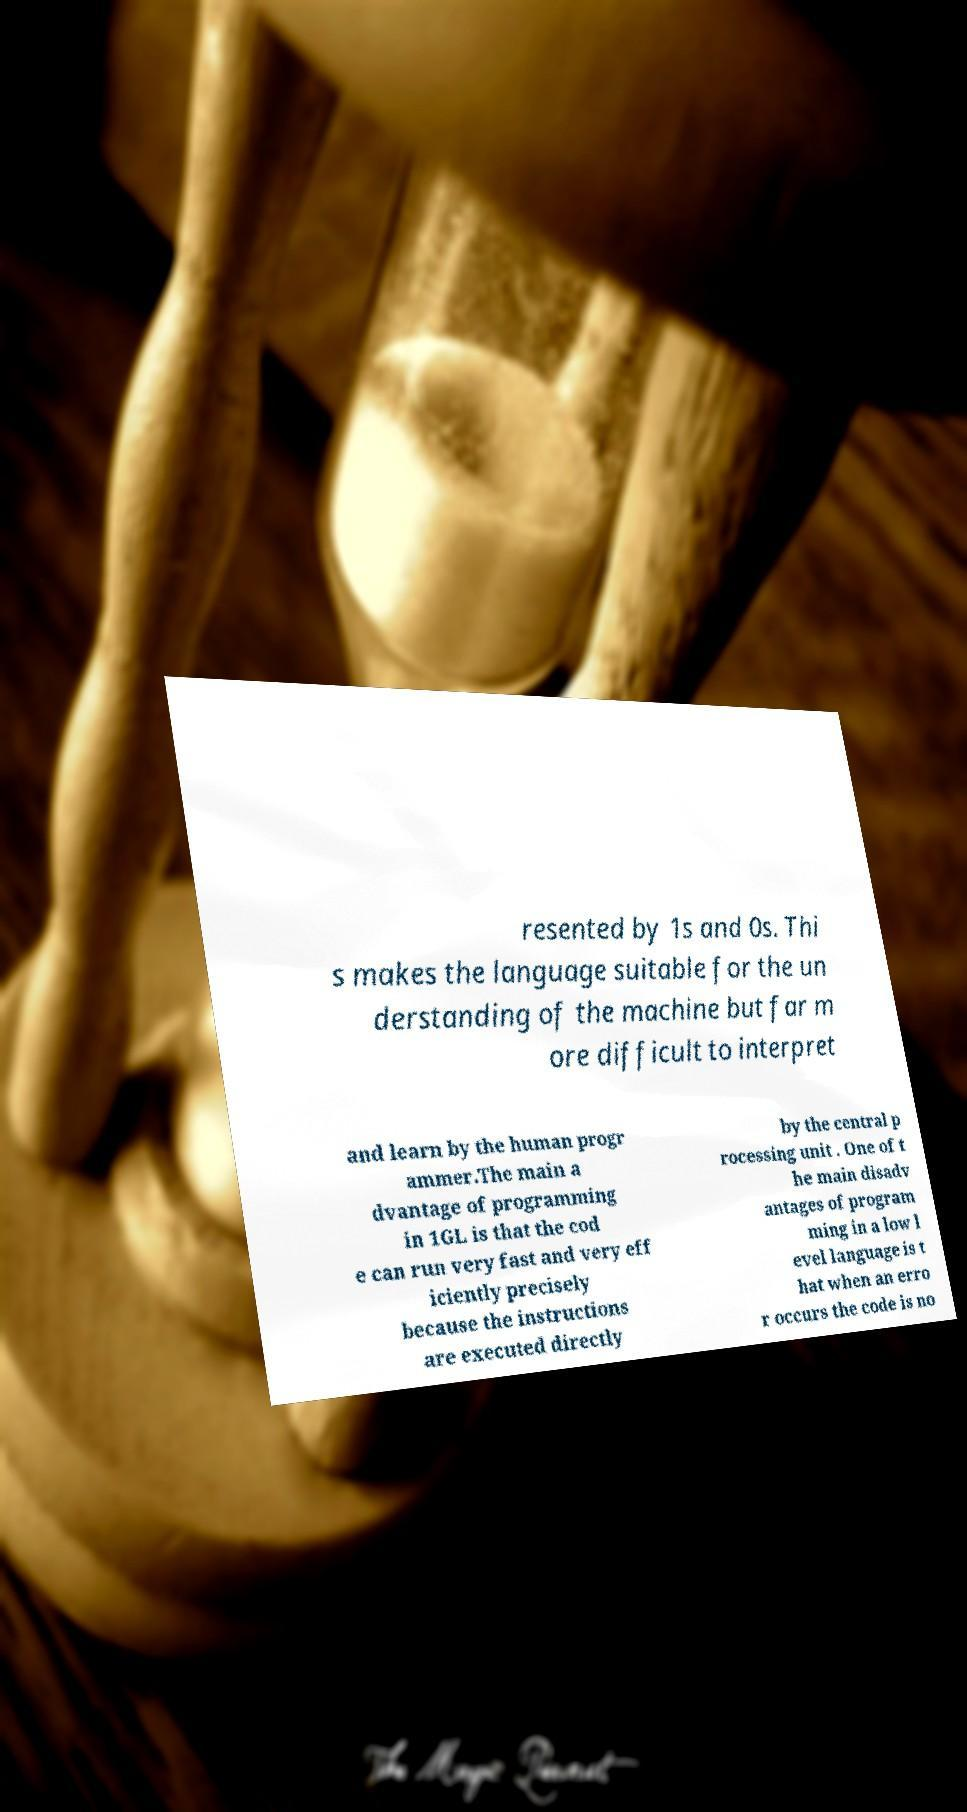Can you accurately transcribe the text from the provided image for me? resented by 1s and 0s. Thi s makes the language suitable for the un derstanding of the machine but far m ore difficult to interpret and learn by the human progr ammer.The main a dvantage of programming in 1GL is that the cod e can run very fast and very eff iciently precisely because the instructions are executed directly by the central p rocessing unit . One of t he main disadv antages of program ming in a low l evel language is t hat when an erro r occurs the code is no 